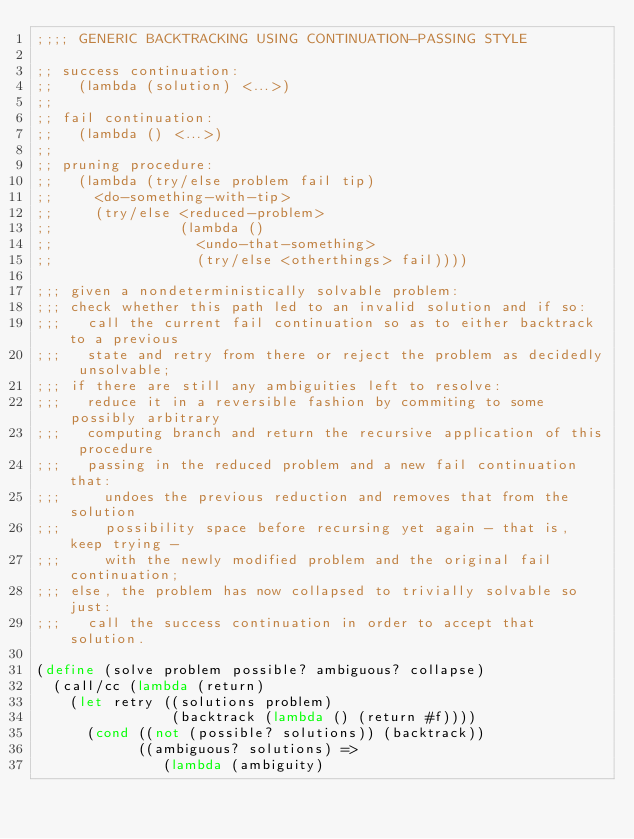<code> <loc_0><loc_0><loc_500><loc_500><_Scheme_>;;;; GENERIC BACKTRACKING USING CONTINUATION-PASSING STYLE

;; success continuation:
;;   (lambda (solution) <...>)
;;
;; fail continuation:
;;   (lambda () <...>)
;;
;; pruning procedure:
;;   (lambda (try/else problem fail tip)
;;     <do-something-with-tip>
;;     (try/else <reduced-problem>
;;               (lambda ()
;;                 <undo-that-something>
;;                 (try/else <otherthings> fail))))

;;; given a nondeterministically solvable problem:
;;; check whether this path led to an invalid solution and if so:
;;;   call the current fail continuation so as to either backtrack to a previous
;;;   state and retry from there or reject the problem as decidedly unsolvable;
;;; if there are still any ambiguities left to resolve:
;;;   reduce it in a reversible fashion by commiting to some possibly arbitrary
;;;   computing branch and return the recursive application of this procedure
;;;   passing in the reduced problem and a new fail continuation that:
;;;     undoes the previous reduction and removes that from the solution
;;;     possibility space before recursing yet again - that is, keep trying -
;;;     with the newly modified problem and the original fail continuation;
;;; else, the problem has now collapsed to trivially solvable so just:
;;;   call the success continuation in order to accept that solution.

(define (solve problem possible? ambiguous? collapse)
  (call/cc (lambda (return)
    (let retry ((solutions problem)
                (backtrack (lambda () (return #f))))
      (cond ((not (possible? solutions)) (backtrack))
            ((ambiguous? solutions) =>
               (lambda (ambiguity)</code> 